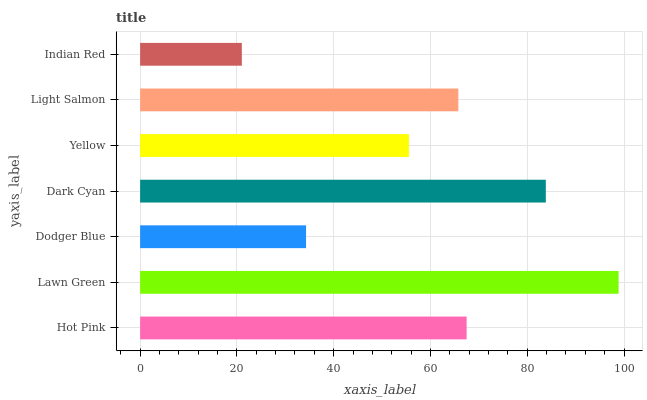Is Indian Red the minimum?
Answer yes or no. Yes. Is Lawn Green the maximum?
Answer yes or no. Yes. Is Dodger Blue the minimum?
Answer yes or no. No. Is Dodger Blue the maximum?
Answer yes or no. No. Is Lawn Green greater than Dodger Blue?
Answer yes or no. Yes. Is Dodger Blue less than Lawn Green?
Answer yes or no. Yes. Is Dodger Blue greater than Lawn Green?
Answer yes or no. No. Is Lawn Green less than Dodger Blue?
Answer yes or no. No. Is Light Salmon the high median?
Answer yes or no. Yes. Is Light Salmon the low median?
Answer yes or no. Yes. Is Dodger Blue the high median?
Answer yes or no. No. Is Indian Red the low median?
Answer yes or no. No. 